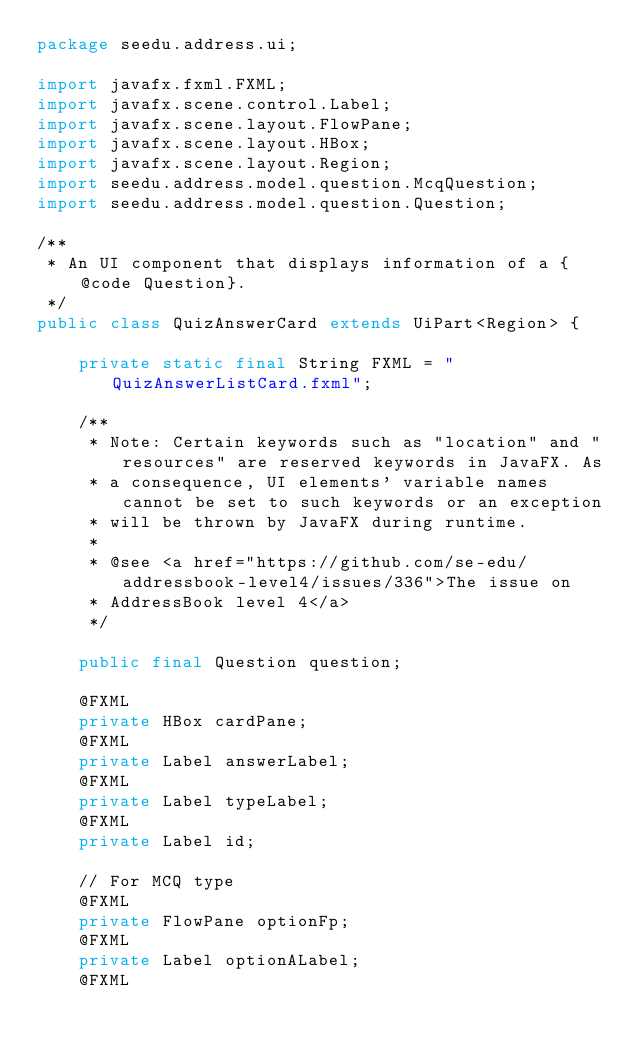Convert code to text. <code><loc_0><loc_0><loc_500><loc_500><_Java_>package seedu.address.ui;

import javafx.fxml.FXML;
import javafx.scene.control.Label;
import javafx.scene.layout.FlowPane;
import javafx.scene.layout.HBox;
import javafx.scene.layout.Region;
import seedu.address.model.question.McqQuestion;
import seedu.address.model.question.Question;

/**
 * An UI component that displays information of a {@code Question}.
 */
public class QuizAnswerCard extends UiPart<Region> {

    private static final String FXML = "QuizAnswerListCard.fxml";

    /**
     * Note: Certain keywords such as "location" and "resources" are reserved keywords in JavaFX. As
     * a consequence, UI elements' variable names cannot be set to such keywords or an exception
     * will be thrown by JavaFX during runtime.
     *
     * @see <a href="https://github.com/se-edu/addressbook-level4/issues/336">The issue on
     * AddressBook level 4</a>
     */

    public final Question question;

    @FXML
    private HBox cardPane;
    @FXML
    private Label answerLabel;
    @FXML
    private Label typeLabel;
    @FXML
    private Label id;

    // For MCQ type
    @FXML
    private FlowPane optionFp;
    @FXML
    private Label optionALabel;
    @FXML</code> 